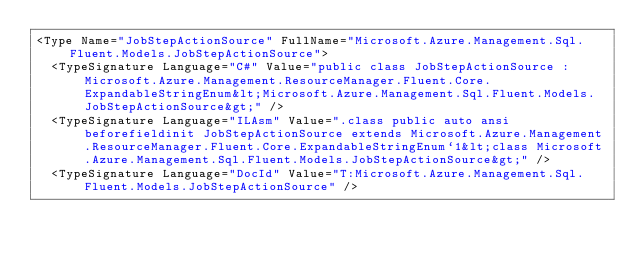<code> <loc_0><loc_0><loc_500><loc_500><_XML_><Type Name="JobStepActionSource" FullName="Microsoft.Azure.Management.Sql.Fluent.Models.JobStepActionSource">
  <TypeSignature Language="C#" Value="public class JobStepActionSource : Microsoft.Azure.Management.ResourceManager.Fluent.Core.ExpandableStringEnum&lt;Microsoft.Azure.Management.Sql.Fluent.Models.JobStepActionSource&gt;" />
  <TypeSignature Language="ILAsm" Value=".class public auto ansi beforefieldinit JobStepActionSource extends Microsoft.Azure.Management.ResourceManager.Fluent.Core.ExpandableStringEnum`1&lt;class Microsoft.Azure.Management.Sql.Fluent.Models.JobStepActionSource&gt;" />
  <TypeSignature Language="DocId" Value="T:Microsoft.Azure.Management.Sql.Fluent.Models.JobStepActionSource" /></code> 